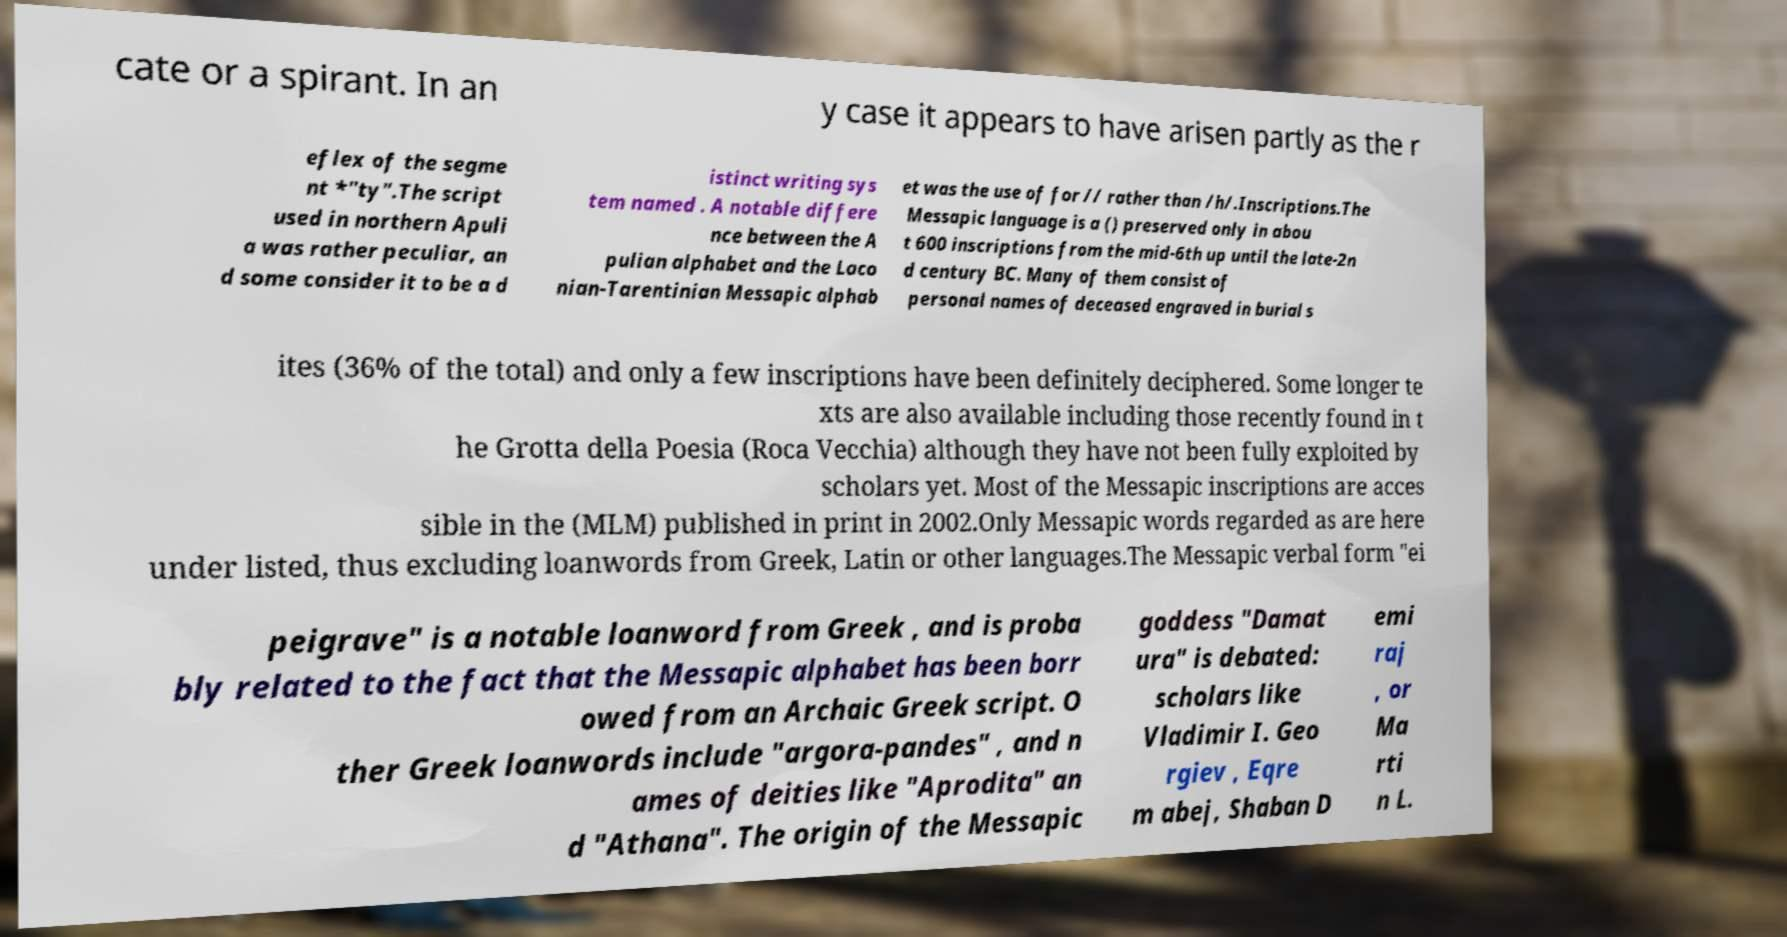Could you assist in decoding the text presented in this image and type it out clearly? cate or a spirant. In an y case it appears to have arisen partly as the r eflex of the segme nt *"ty".The script used in northern Apuli a was rather peculiar, an d some consider it to be a d istinct writing sys tem named . A notable differe nce between the A pulian alphabet and the Laco nian-Tarentinian Messapic alphab et was the use of for // rather than /h/.Inscriptions.The Messapic language is a () preserved only in abou t 600 inscriptions from the mid-6th up until the late-2n d century BC. Many of them consist of personal names of deceased engraved in burial s ites (36% of the total) and only a few inscriptions have been definitely deciphered. Some longer te xts are also available including those recently found in t he Grotta della Poesia (Roca Vecchia) although they have not been fully exploited by scholars yet. Most of the Messapic inscriptions are acces sible in the (MLM) published in print in 2002.Only Messapic words regarded as are here under listed, thus excluding loanwords from Greek, Latin or other languages.The Messapic verbal form "ei peigrave" is a notable loanword from Greek , and is proba bly related to the fact that the Messapic alphabet has been borr owed from an Archaic Greek script. O ther Greek loanwords include "argora-pandes" , and n ames of deities like "Aprodita" an d "Athana". The origin of the Messapic goddess "Damat ura" is debated: scholars like Vladimir I. Geo rgiev , Eqre m abej, Shaban D emi raj , or Ma rti n L. 